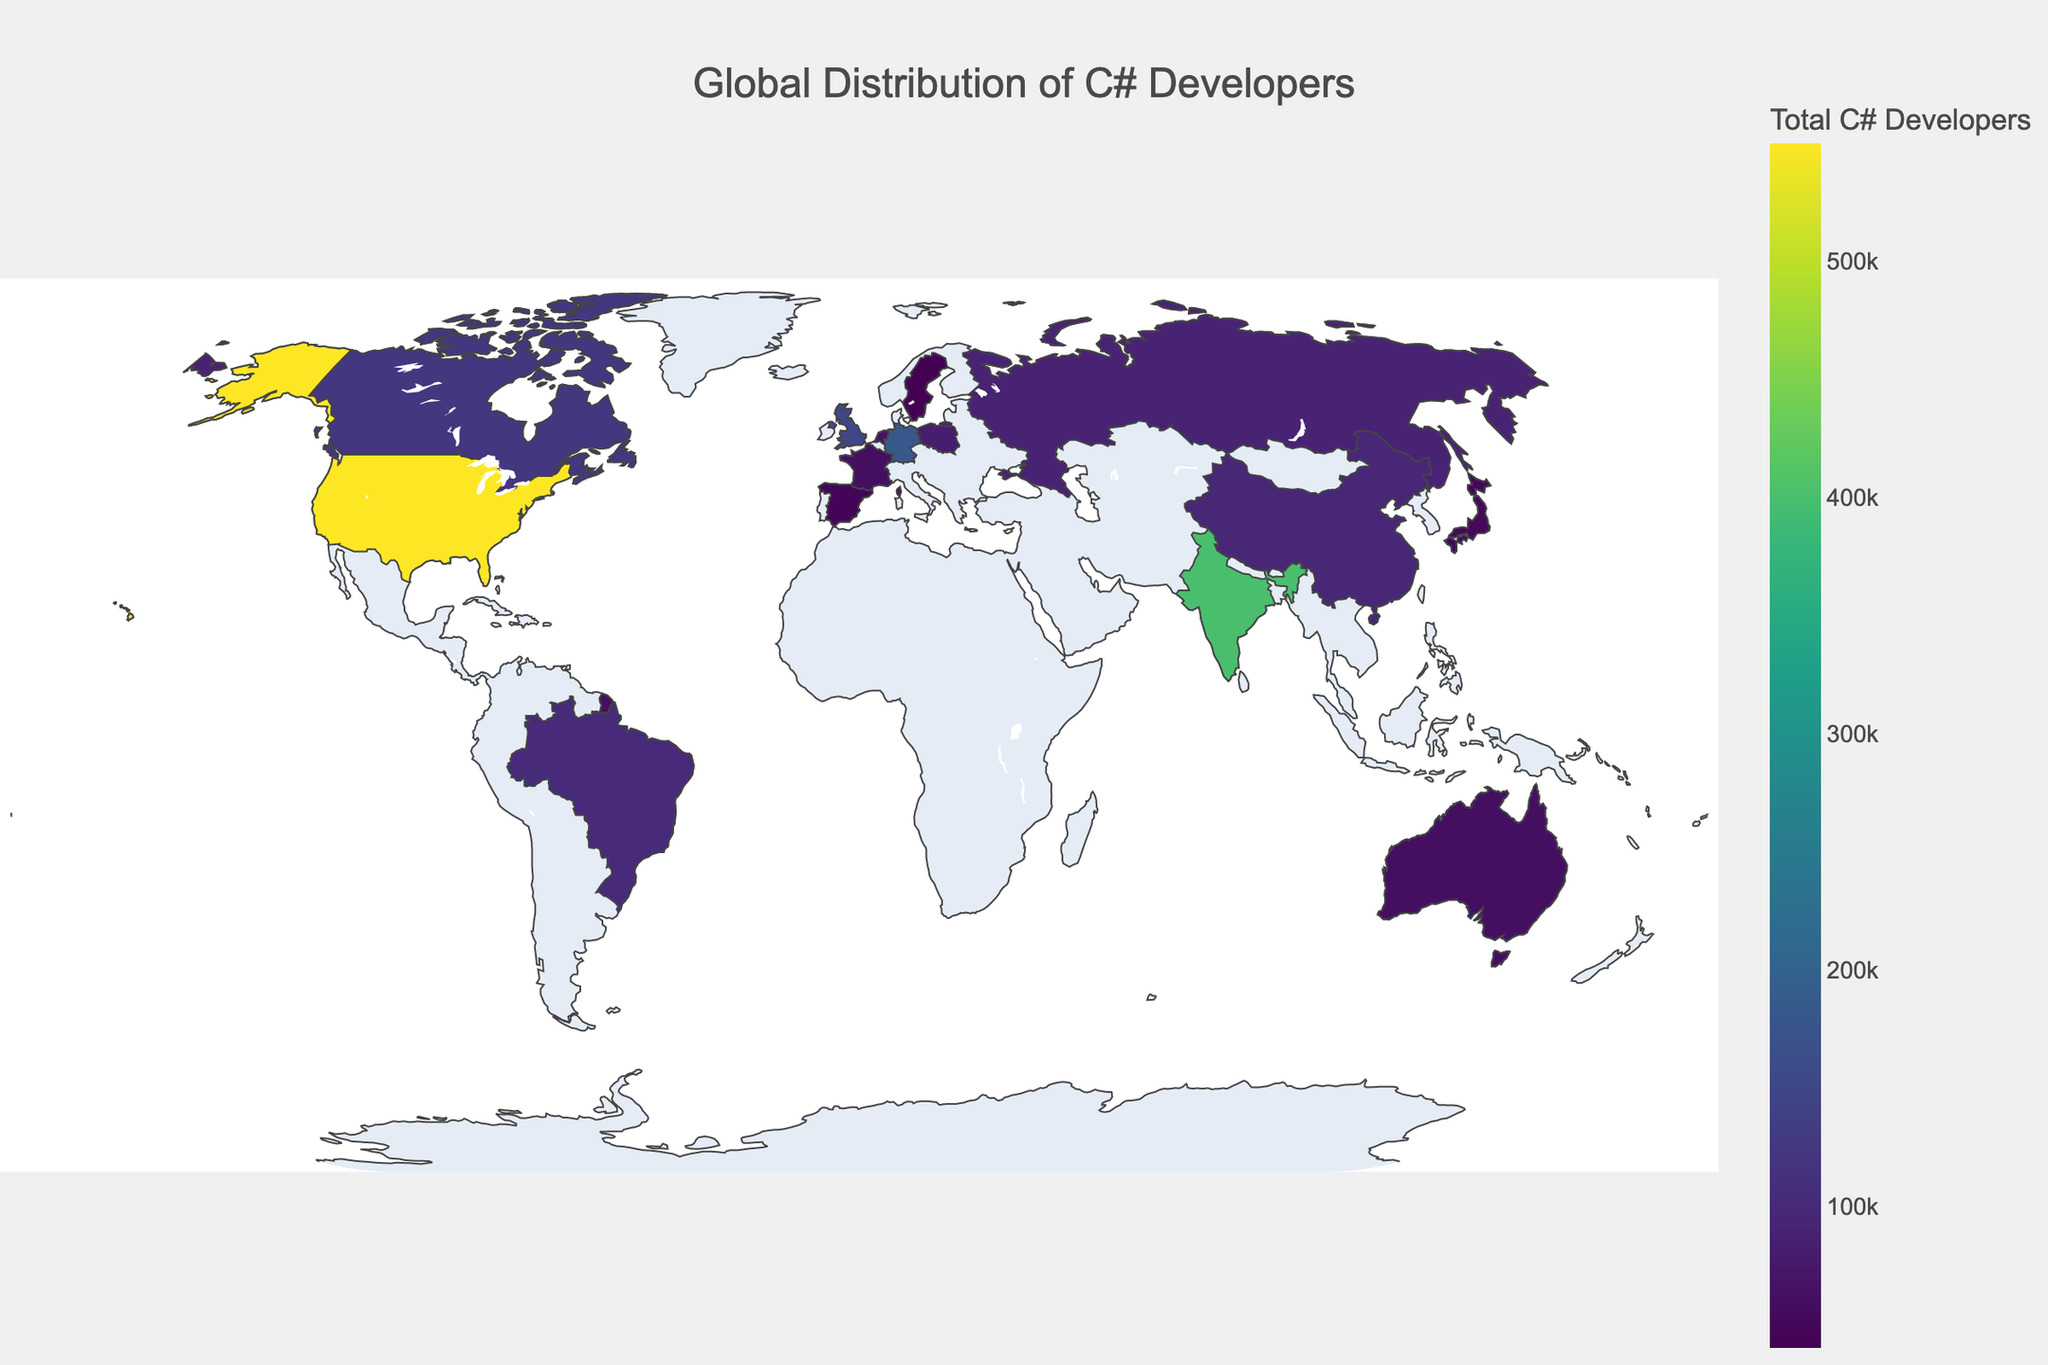Which country has the highest number of total C# developers? To determine the country with the highest number of total C# developers, look at the data for the 'Total' column and identify the highest value. The United States has 550,000 total developers, which is the highest.
Answer: United States Which country has the second-highest number of senior C# developers? To find the country with the second-highest number of senior developers, examine the 'Senior' column and identify the second-largest value. The United States has the highest (180,000), and Germany is second with 60,000.
Answer: Germany What is the total number of C# developers in Europe (consider Germany, United Kingdom, Poland, Netherlands, France, Sweden)? Sum the 'Total' values for the European countries listed: Germany (180,000) + United Kingdom (150,000) + Poland (80,000) + Netherlands (65,000) + France (60,000) + Sweden (40,000). The sum is 575,000.
Answer: 575,000 Which country has the lowest number of junior C# developers? To find the country with the lowest number of junior developers, look at the 'Junior' column and identify the smallest value. Both Australia and Spain have 15,000, which is the lowest value.
Answer: Australia or Spain How does the number of intermediate-level C# developers in India compare to the United States? Compare the 'Intermediate' values for India (140,000) and the United States (220,000). India has fewer intermediate C# developers than the United States.
Answer: India has fewer What percentage of the total C# developers in Canada are senior-level? Calculate the percentage of senior developers in Canada by dividing the senior value (40,000) by the total value (120,000) and multiplying by 100. (40,000 / 120,000) * 100 = 33.33%.
Answer: 33.33% Which region (North America, Europe, or Asia) has the highest aggregate number of C# developers? (Consider North America: United States, Canada; Europe: Germany, United Kingdom, Poland, Netherlands, France, Sweden; Asia: India, China, Japan) Sum the 'Total' values for each region. North America: United States (550,000) + Canada (120,000) = 670,000. Europe: Germany (180,000) + United Kingdom (150,000) + Poland (80,000) + Netherlands (65,000) + France (60,000) + Sweden (40,000) = 575,000. Asia: India (400,000) + China (95,000) + Japan (50,000) = 545,000. North America has the highest total with 670,000 developers.
Answer: North America What is the distribution of junior developers across the countries with the least number having fewer than 20,000 junior developers? Identify and count the countries with fewer than 20,000 junior developers: Netherlands (20,000), France (20,000), Japan (15,000), Spain (15,000), Sweden (10,000). Only Sweden meets the criterion with fewer than 20,000.
Answer: Sweden Which country has a higher ratio of senior to junior developers, China or Brazil? Calculate the ratio of senior to junior developers for both countries. China: 25,000 seniors / 40,000 juniors = 0.625. Brazil: 20,000 seniors / 45,000 juniors = 0.444. China has a higher ratio of senior to junior developers.
Answer: China What is the overall average number of C# developers per country? Sum the 'Total' values for all countries and divide by the number of countries. Total sum is 2,330,000 across 15 countries. The average is 2,330,000 / 15 = 155,333.33.
Answer: 155,333.33 